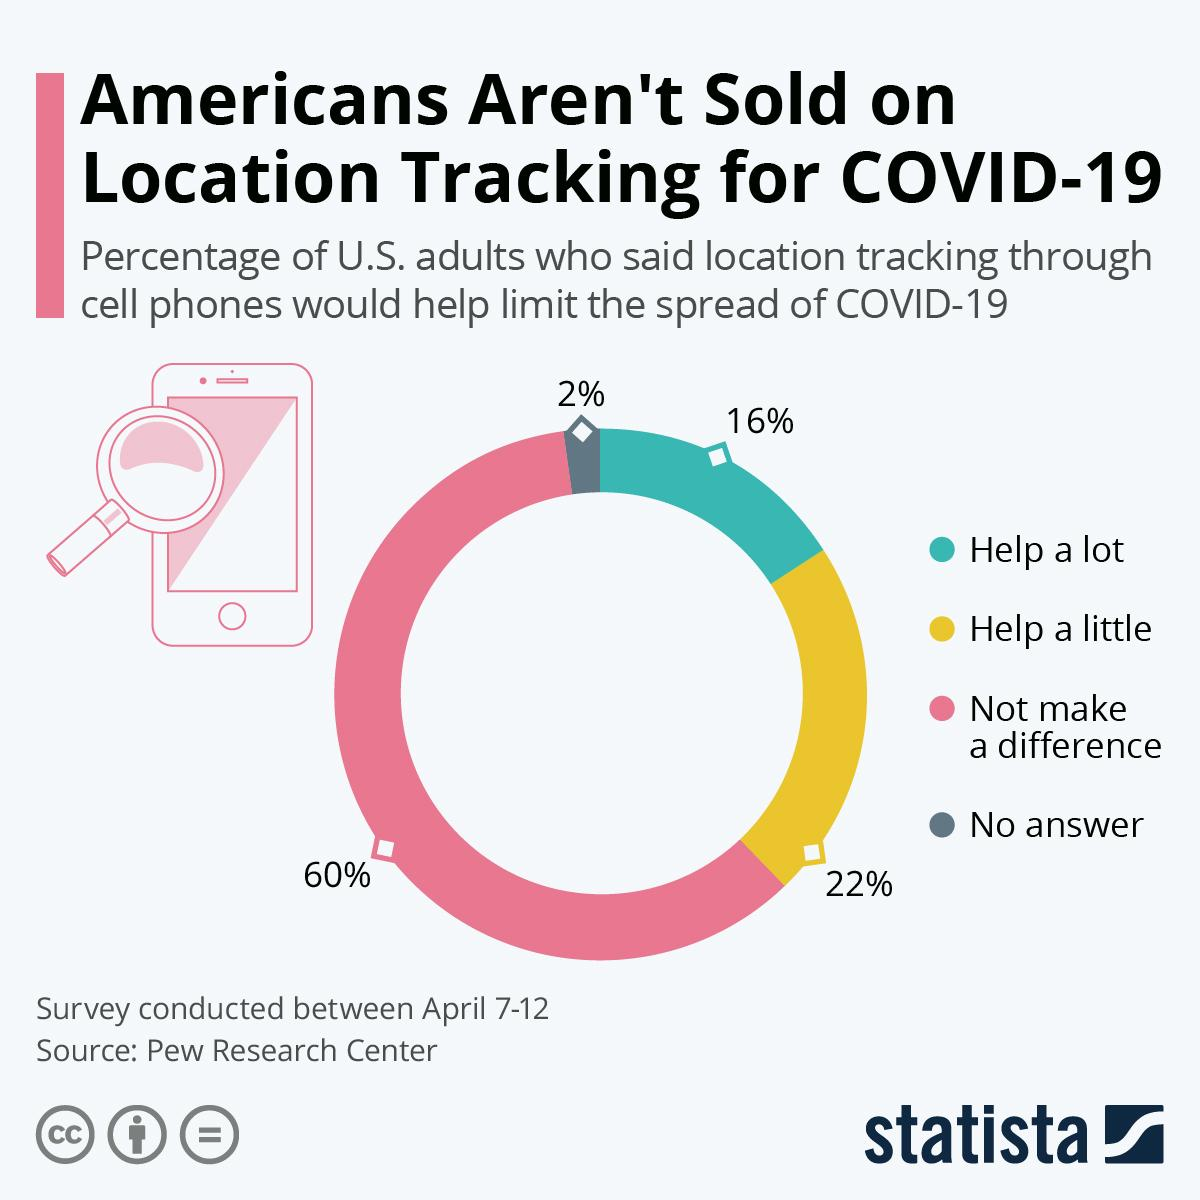Point out several critical features in this image. The majority of Americans hold the opinion that the use of location tracking to limit the spread of disease makes no difference. In response to the spread of COVID-19, a small percentage of people, only 2%, refused to allow location tracking to limit the spread of the virus. According to a survey, 16% of people believe that location tracking would be effective in limiting the spread of COVID-19. According to a recent survey, 22% of people believe that location tracking would be helpful in limiting the spread of COVID-19. According to the survey, 38% of the respondents believe that location tracking will be helpful in limiting the spread of the disease. 